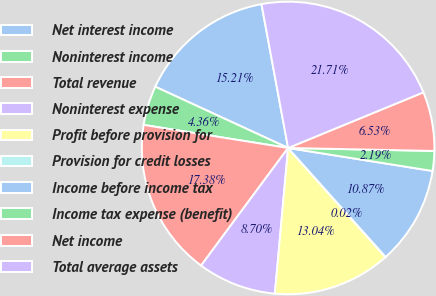<chart> <loc_0><loc_0><loc_500><loc_500><pie_chart><fcel>Net interest income<fcel>Noninterest income<fcel>Total revenue<fcel>Noninterest expense<fcel>Profit before provision for<fcel>Provision for credit losses<fcel>Income before income tax<fcel>Income tax expense (benefit)<fcel>Net income<fcel>Total average assets<nl><fcel>15.21%<fcel>4.36%<fcel>17.38%<fcel>8.7%<fcel>13.04%<fcel>0.02%<fcel>10.87%<fcel>2.19%<fcel>6.53%<fcel>21.71%<nl></chart> 